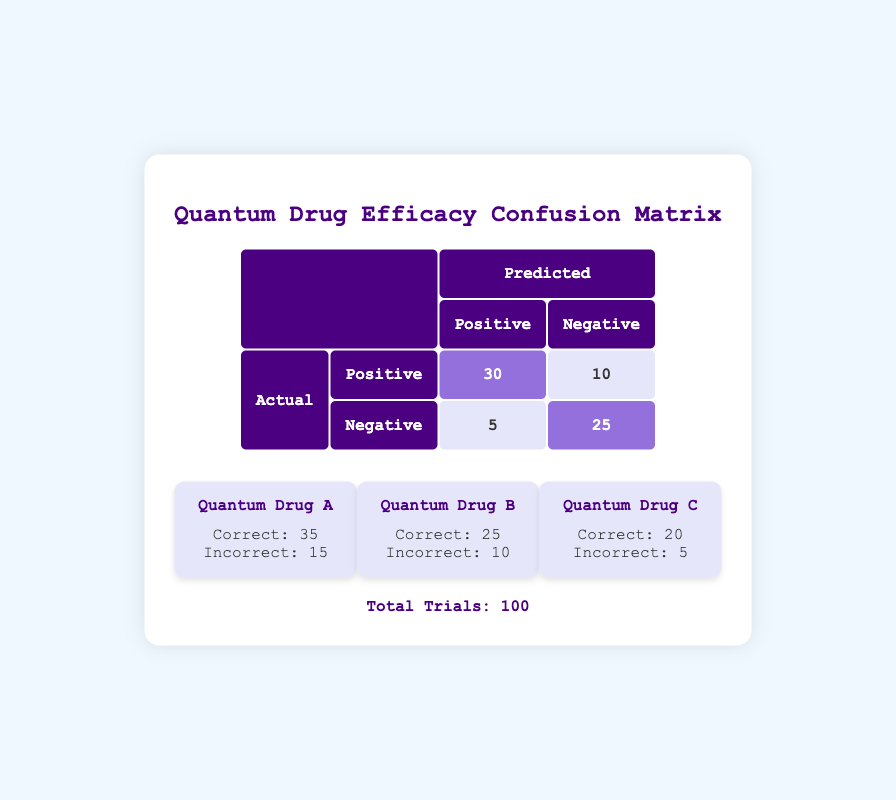What is the total number of positive predictions made? To find the total number of positive predictions, add the true positives (30) to the false positives (5), which gives 30 + 5 = 35.
Answer: 35 How many trials resulted in negative predictions? The negative predictions consist of true negatives (25) plus false negatives (10). Therefore, total negative predictions = 25 + 10 = 35.
Answer: 35 Which quantum drug achieved the highest number of correctly predicted outcomes? Looking at the results, Quantum Drug A (35) has the highest number of correctly predicted outcomes compared to Quantum Drug B (25) and Quantum Drug C (20).
Answer: Quantum Drug A What percentage of the total trials were misclassified? Misclassified outcomes are the sum of false positives (5) and false negatives (10), which equals 5 + 10 = 15. The percentage is then (15/100) * 100% = 15%.
Answer: 15% Is it true that Quantum Drug B had more incorrectly predicted outcomes than Quantum Drug C? Quantum Drug B had 10 incorrect predictions, while Quantum Drug C had 5, making the statement true.
Answer: Yes How many total correct predictions were made across all drug treatments? The total correct predictions are the sum of correctly predicted outcomes for all drugs: Quantum Drug A (35) + Quantum Drug B (25) + Quantum Drug C (20) = 35 + 25 + 20 = 80.
Answer: 80 Which treatment group had the fewest correct predictions, and how many were they? Quantum Drug C had the fewest correct predictions with a total of 20.
Answer: Quantum Drug C, 20 What is the ratio of true positives to total trials? The ratio of true positives (30) to total trials (100) is 30:100, which simplifies to 3:10.
Answer: 3:10 What is the total number of incorrect predictions across all drug treatments? The total incorrect predictions are the sum of incorrectly predicted outcomes for all drugs: Quantum Drug A (15) + Quantum Drug B (10) + Quantum Drug C (5) = 15 + 10 + 5 = 30.
Answer: 30 